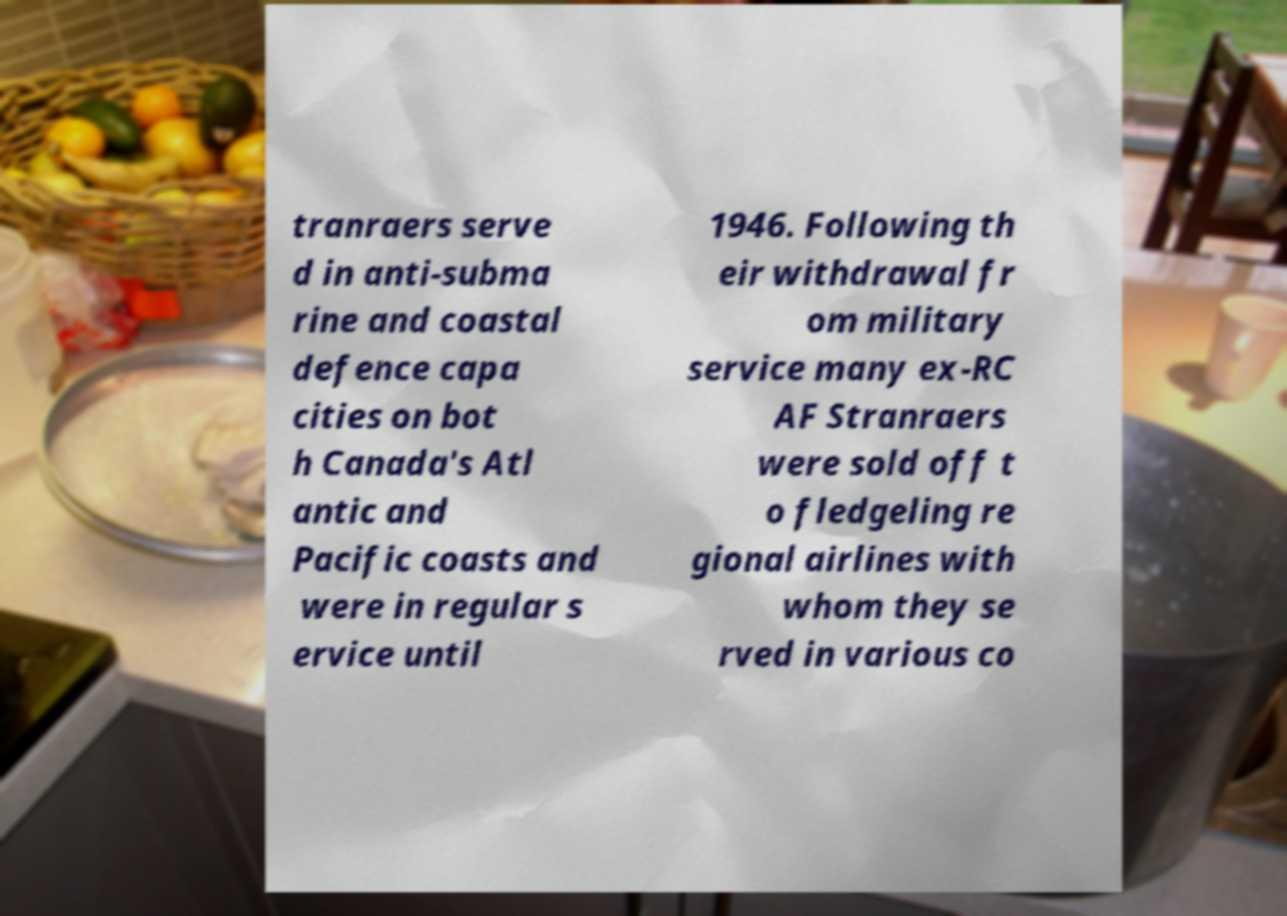Please read and relay the text visible in this image. What does it say? tranraers serve d in anti-subma rine and coastal defence capa cities on bot h Canada's Atl antic and Pacific coasts and were in regular s ervice until 1946. Following th eir withdrawal fr om military service many ex-RC AF Stranraers were sold off t o fledgeling re gional airlines with whom they se rved in various co 